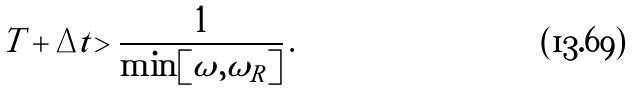Convert formula to latex. <formula><loc_0><loc_0><loc_500><loc_500>T + \Delta t > \frac { 1 } { \min [ \omega , \omega _ { R } ] } \, .</formula> 